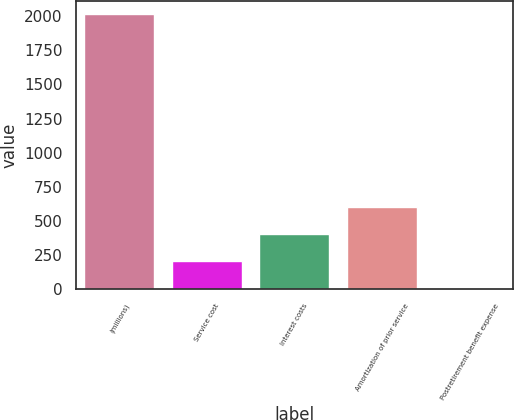Convert chart. <chart><loc_0><loc_0><loc_500><loc_500><bar_chart><fcel>(millions)<fcel>Service cost<fcel>Interest costs<fcel>Amortization of prior service<fcel>Postretirement benefit expense<nl><fcel>2011<fcel>204.16<fcel>404.92<fcel>605.68<fcel>3.4<nl></chart> 